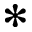Convert formula to latex. <formula><loc_0><loc_0><loc_500><loc_500>\ast</formula> 